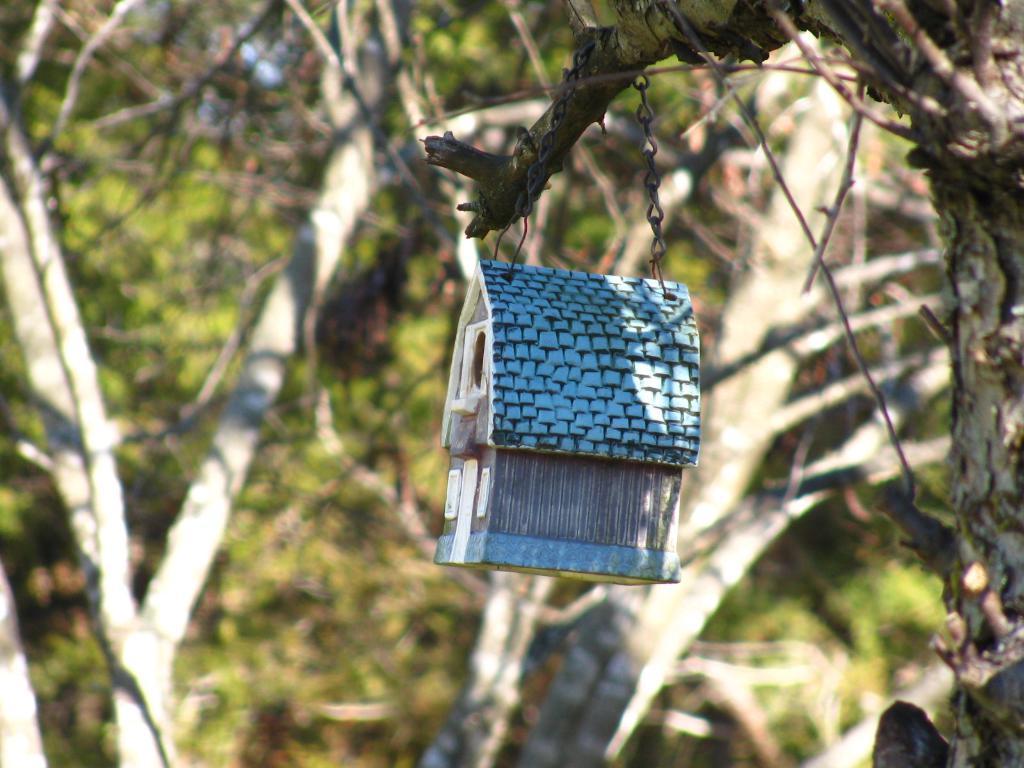Can you describe this image briefly? In this image I can see a house hanged to the branch and the house is in blue color. Background I can see trees in green color. 